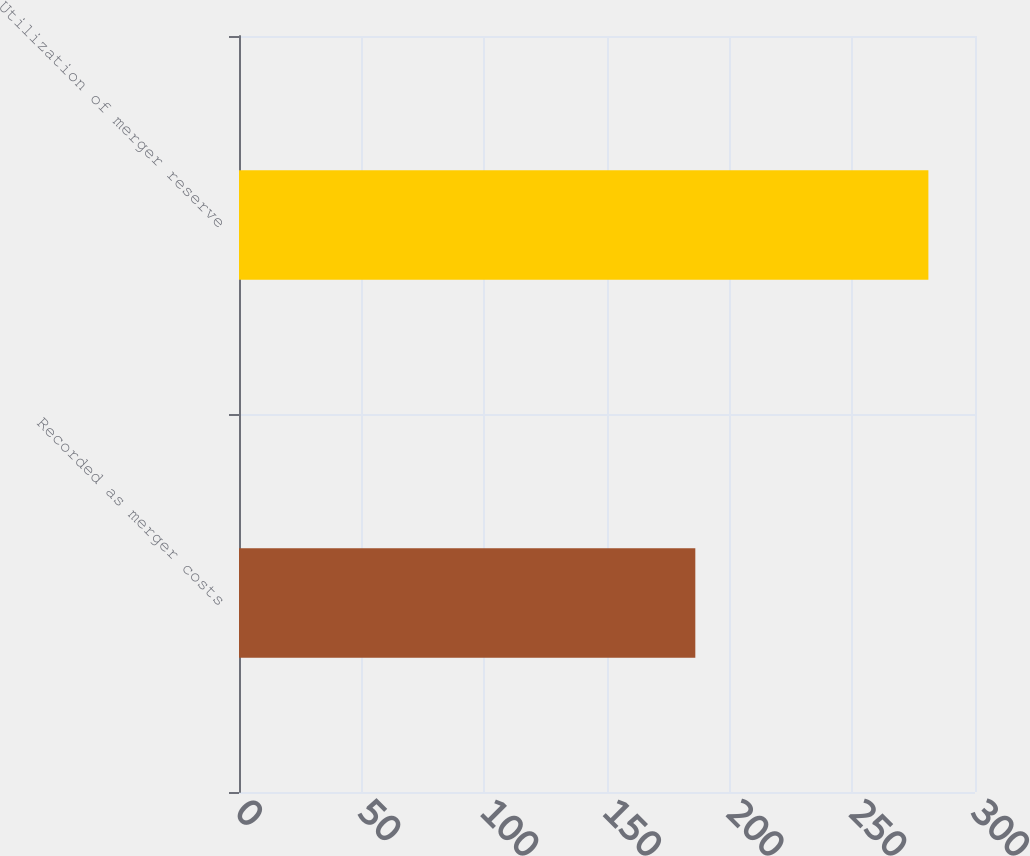Convert chart to OTSL. <chart><loc_0><loc_0><loc_500><loc_500><bar_chart><fcel>Recorded as merger costs<fcel>Utilization of merger reserve<nl><fcel>186<fcel>281<nl></chart> 